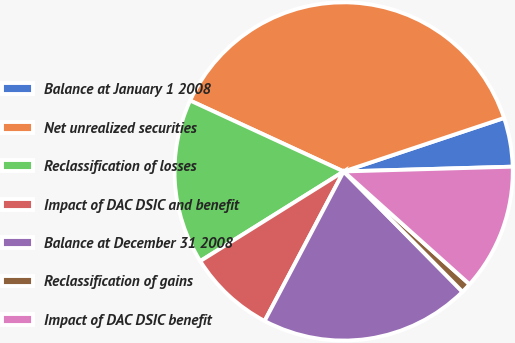Convert chart. <chart><loc_0><loc_0><loc_500><loc_500><pie_chart><fcel>Balance at January 1 2008<fcel>Net unrealized securities<fcel>Reclassification of losses<fcel>Impact of DAC DSIC and benefit<fcel>Balance at December 31 2008<fcel>Reclassification of gains<fcel>Impact of DAC DSIC benefit<nl><fcel>4.67%<fcel>37.99%<fcel>15.78%<fcel>8.37%<fcel>20.14%<fcel>0.97%<fcel>12.08%<nl></chart> 